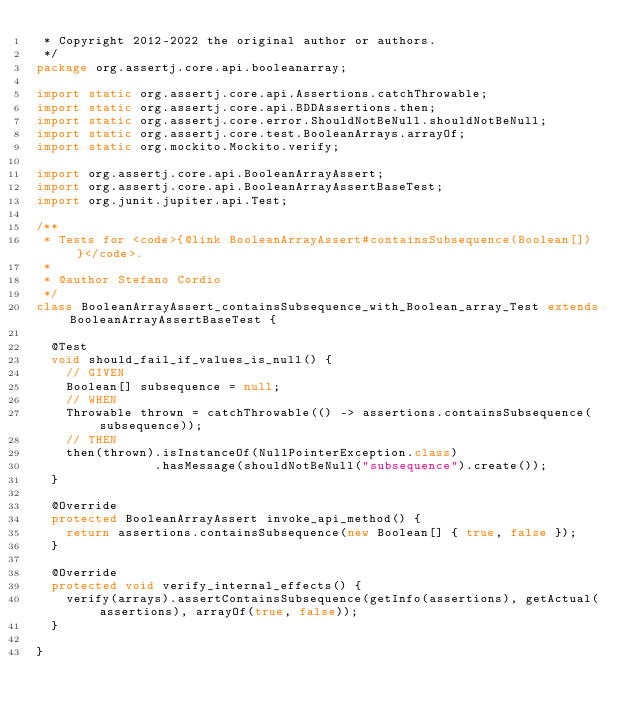<code> <loc_0><loc_0><loc_500><loc_500><_Java_> * Copyright 2012-2022 the original author or authors.
 */
package org.assertj.core.api.booleanarray;

import static org.assertj.core.api.Assertions.catchThrowable;
import static org.assertj.core.api.BDDAssertions.then;
import static org.assertj.core.error.ShouldNotBeNull.shouldNotBeNull;
import static org.assertj.core.test.BooleanArrays.arrayOf;
import static org.mockito.Mockito.verify;

import org.assertj.core.api.BooleanArrayAssert;
import org.assertj.core.api.BooleanArrayAssertBaseTest;
import org.junit.jupiter.api.Test;

/**
 * Tests for <code>{@link BooleanArrayAssert#containsSubsequence(Boolean[])}</code>.
 * 
 * @author Stefano Cordio
 */
class BooleanArrayAssert_containsSubsequence_with_Boolean_array_Test extends BooleanArrayAssertBaseTest {

  @Test
  void should_fail_if_values_is_null() {
    // GIVEN
    Boolean[] subsequence = null;
    // WHEN
    Throwable thrown = catchThrowable(() -> assertions.containsSubsequence(subsequence));
    // THEN
    then(thrown).isInstanceOf(NullPointerException.class)
                .hasMessage(shouldNotBeNull("subsequence").create());
  }

  @Override
  protected BooleanArrayAssert invoke_api_method() {
    return assertions.containsSubsequence(new Boolean[] { true, false });
  }

  @Override
  protected void verify_internal_effects() {
    verify(arrays).assertContainsSubsequence(getInfo(assertions), getActual(assertions), arrayOf(true, false));
  }

}
</code> 